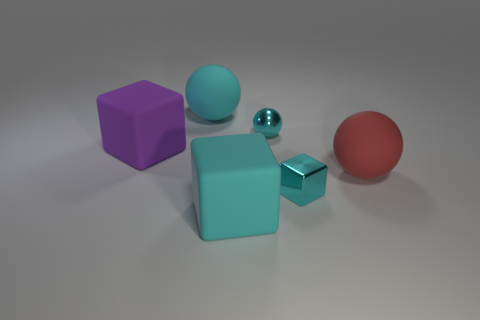What number of objects are either small metal objects that are behind the small cyan cube or cyan rubber balls?
Your response must be concise. 2. Is the number of balls on the left side of the purple rubber cube less than the number of shiny spheres that are right of the small cyan sphere?
Give a very brief answer. No. There is a shiny cube; are there any large purple blocks right of it?
Keep it short and to the point. No. What number of objects are either large cyan rubber objects behind the red rubber thing or small metal balls that are behind the purple object?
Your answer should be compact. 2. What number of tiny cubes are the same color as the tiny metallic ball?
Make the answer very short. 1. What color is the other matte object that is the same shape as the large purple thing?
Make the answer very short. Cyan. What shape is the matte thing that is both behind the big red rubber sphere and right of the large purple block?
Provide a short and direct response. Sphere. Are there more big red matte things than big rubber objects?
Your answer should be compact. No. What is the material of the tiny cyan cube?
Provide a short and direct response. Metal. Is there any other thing that has the same size as the purple cube?
Your response must be concise. Yes. 